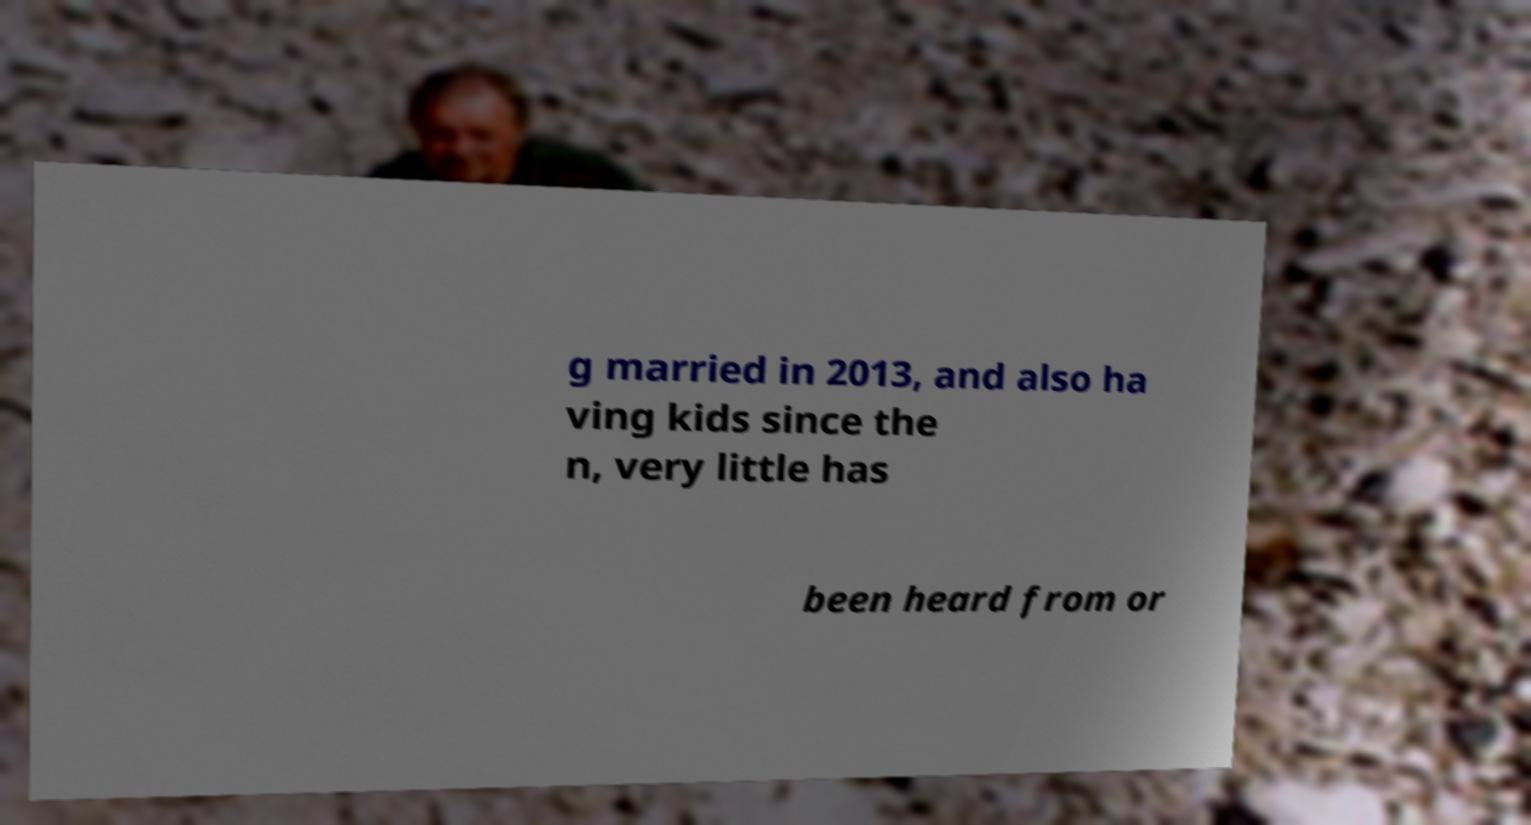I need the written content from this picture converted into text. Can you do that? g married in 2013, and also ha ving kids since the n, very little has been heard from or 